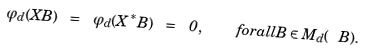<formula> <loc_0><loc_0><loc_500><loc_500>\varphi _ { d } ( X B ) \ = \ \varphi _ { d } ( X ^ { * } B ) \ = \ 0 , \quad f o r a l l B \in M _ { d } ( \ B ) .</formula> 